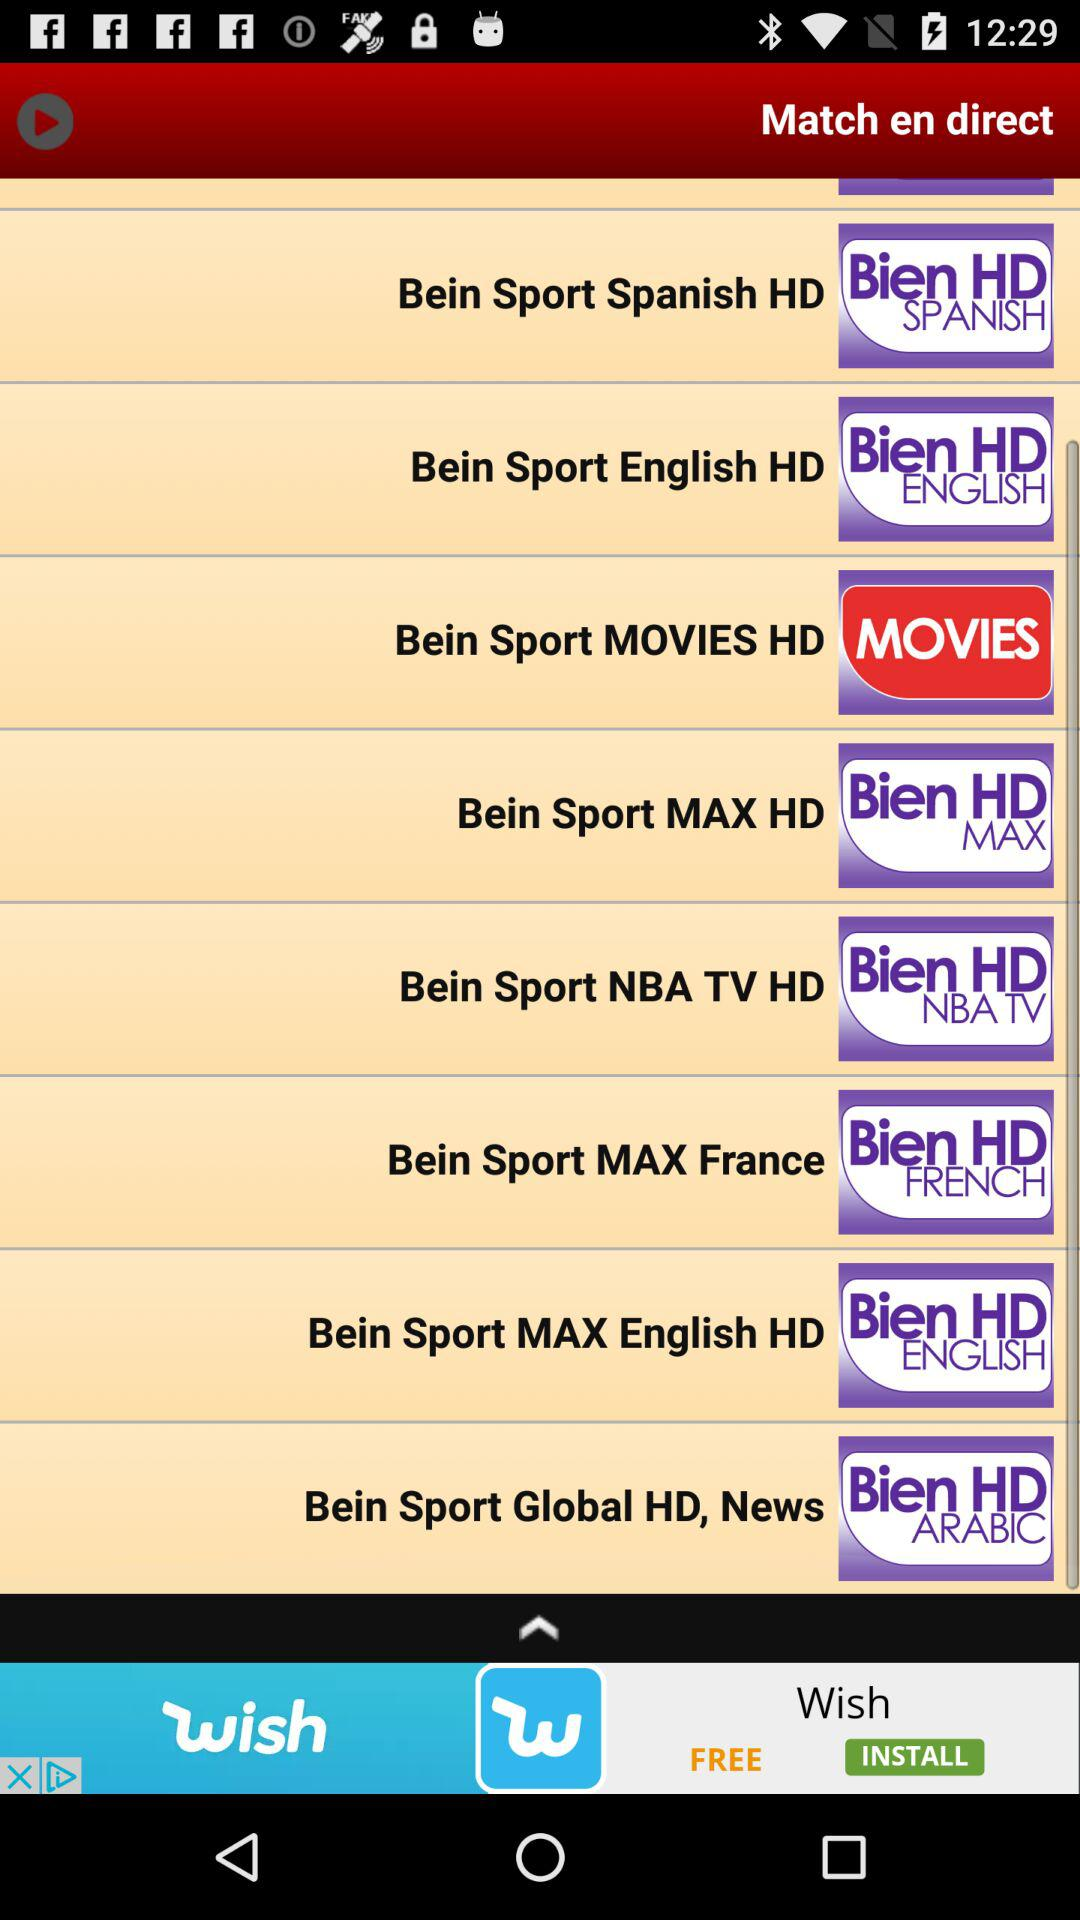How many Bein Sport channels are there in total?
Answer the question using a single word or phrase. 8 